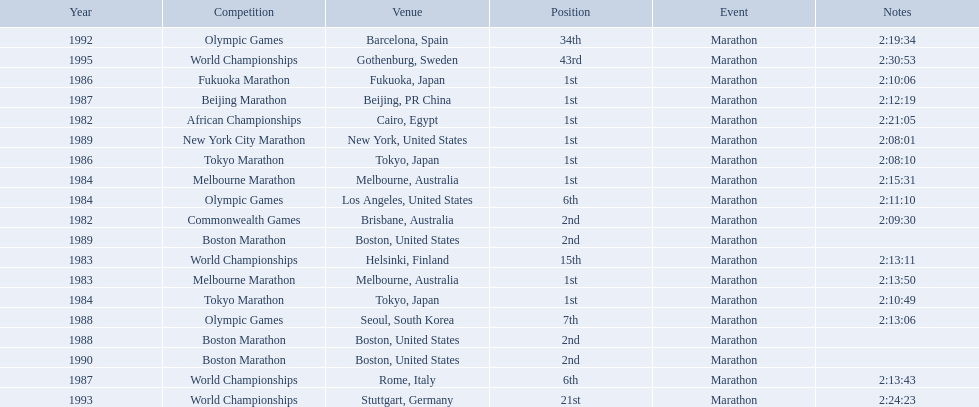What are all of the juma ikangaa competitions? African Championships, Commonwealth Games, World Championships, Melbourne Marathon, Tokyo Marathon, Olympic Games, Melbourne Marathon, Tokyo Marathon, Fukuoka Marathon, World Championships, Beijing Marathon, Olympic Games, Boston Marathon, New York City Marathon, Boston Marathon, Boston Marathon, Olympic Games, World Championships, World Championships. Which of these competitions did not take place in the united states? African Championships, Commonwealth Games, World Championships, Melbourne Marathon, Tokyo Marathon, Melbourne Marathon, Tokyo Marathon, Fukuoka Marathon, World Championships, Beijing Marathon, Olympic Games, Olympic Games, World Championships, World Championships. Out of these, which of them took place in asia? Tokyo Marathon, Tokyo Marathon, Fukuoka Marathon, Beijing Marathon, Olympic Games. Which of the remaining competitions took place in china? Beijing Marathon. 